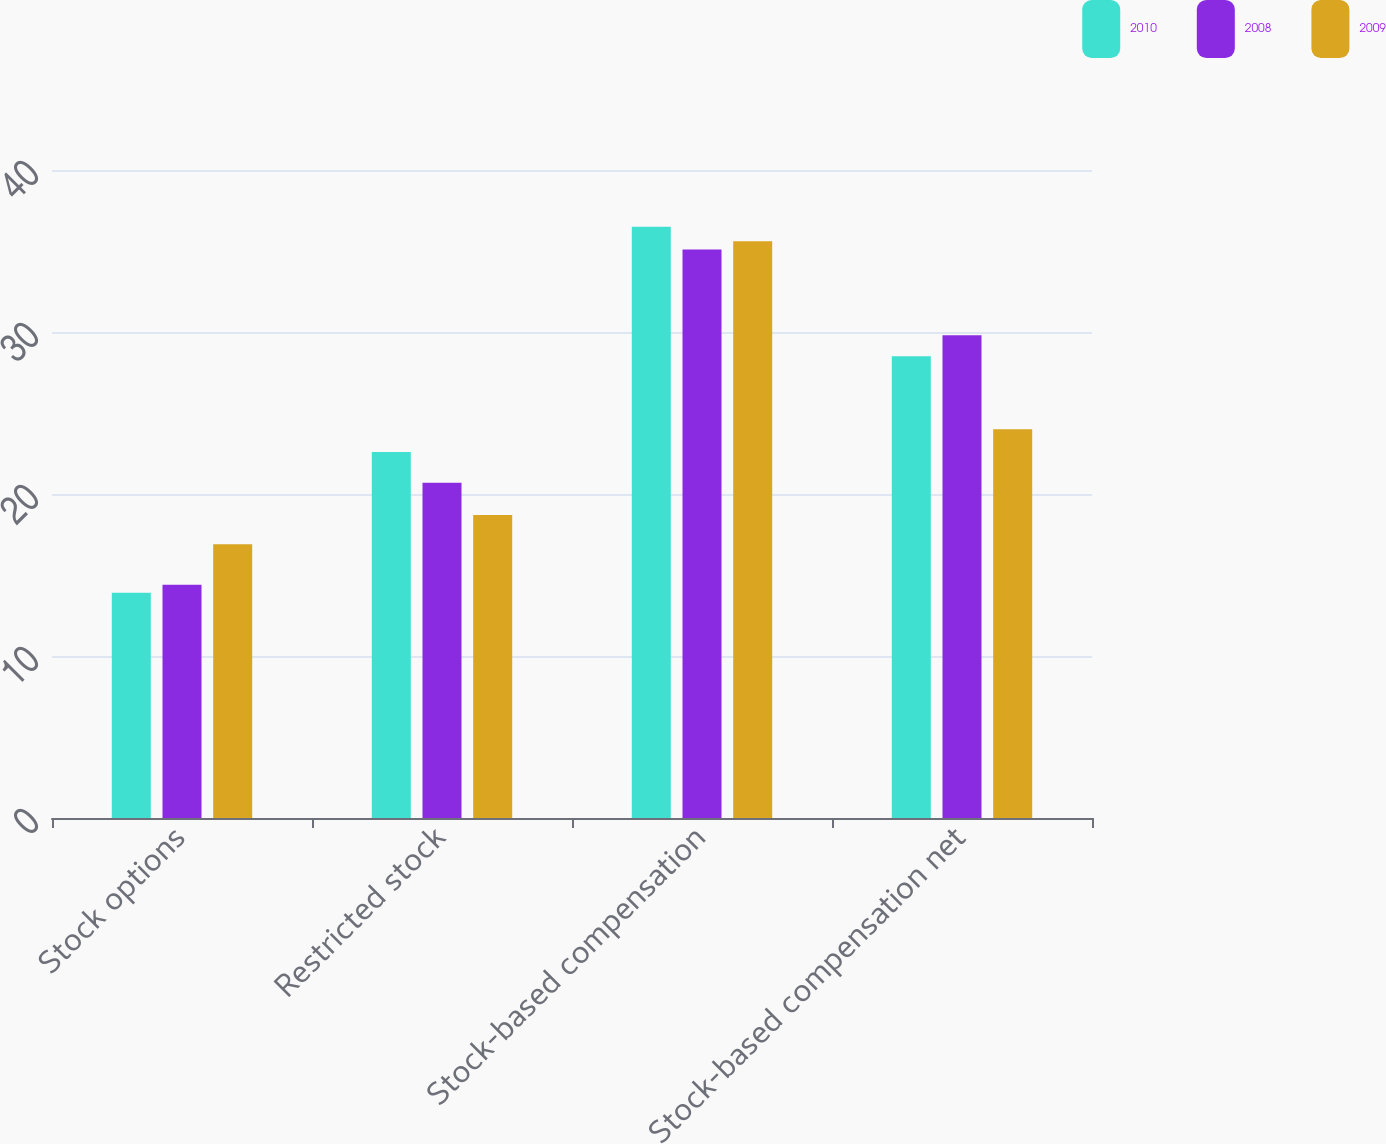<chart> <loc_0><loc_0><loc_500><loc_500><stacked_bar_chart><ecel><fcel>Stock options<fcel>Restricted stock<fcel>Stock-based compensation<fcel>Stock-based compensation net<nl><fcel>2010<fcel>13.9<fcel>22.6<fcel>36.5<fcel>28.5<nl><fcel>2008<fcel>14.4<fcel>20.7<fcel>35.1<fcel>29.8<nl><fcel>2009<fcel>16.9<fcel>18.7<fcel>35.6<fcel>24<nl></chart> 